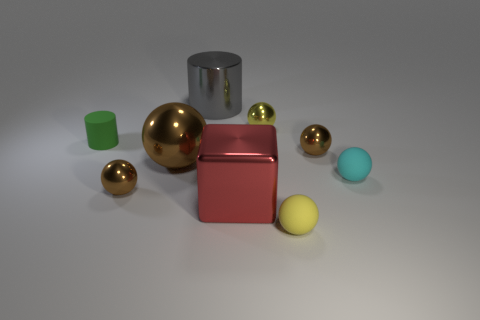Subtract all gray cylinders. How many brown balls are left? 3 Subtract all rubber balls. How many balls are left? 4 Subtract 1 spheres. How many spheres are left? 5 Subtract all cyan spheres. How many spheres are left? 5 Subtract all gray balls. Subtract all red cubes. How many balls are left? 6 Subtract all balls. How many objects are left? 3 Add 4 yellow rubber things. How many yellow rubber things exist? 5 Subtract 0 brown cylinders. How many objects are left? 9 Subtract all small things. Subtract all large red things. How many objects are left? 2 Add 3 rubber balls. How many rubber balls are left? 5 